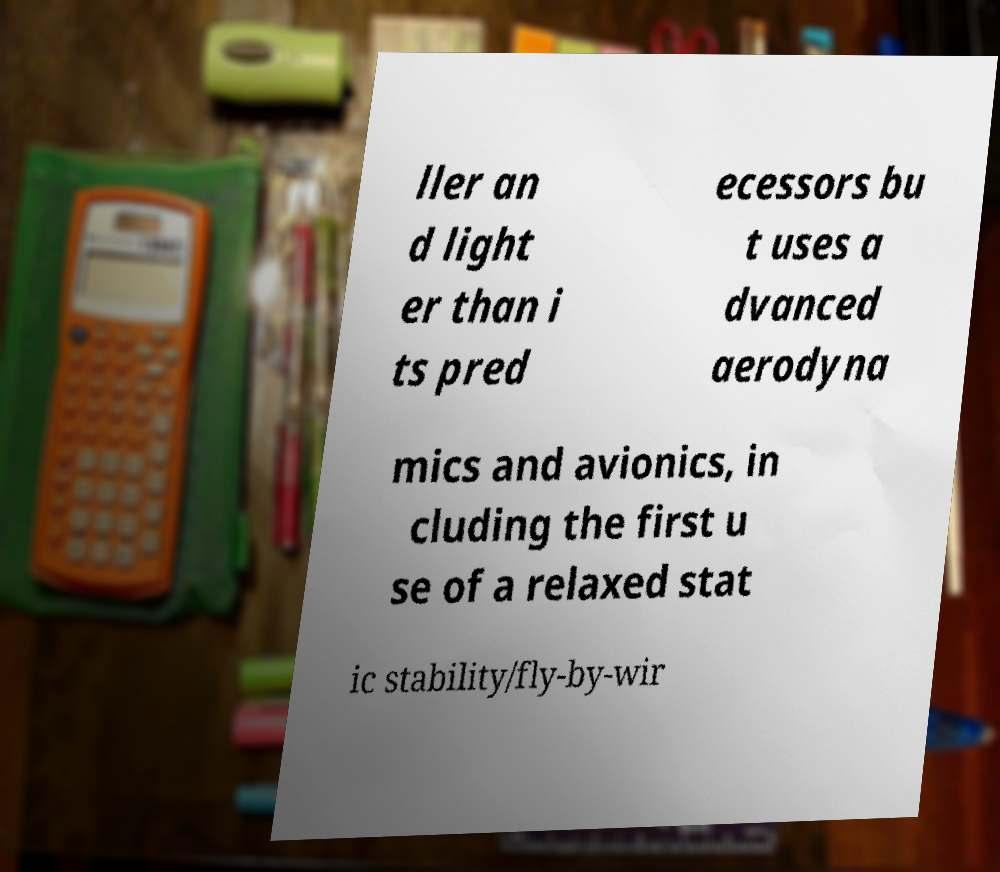I need the written content from this picture converted into text. Can you do that? ller an d light er than i ts pred ecessors bu t uses a dvanced aerodyna mics and avionics, in cluding the first u se of a relaxed stat ic stability/fly-by-wir 